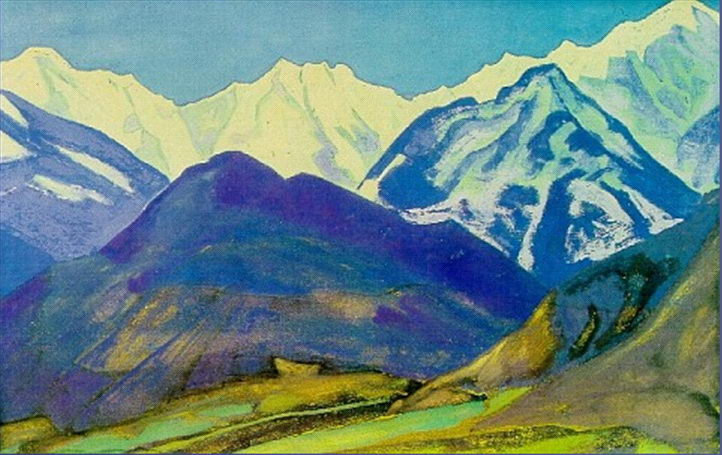Analyze the image in a comprehensive and detailed manner. The image is a vibrant depiction of a mountainous landscape, rendered in a post-impressionist style that embraces bold, expressive colors and dynamic brushstrokes. The mountains themselves are layered in hues of blue, green, and purple, each ridge and peak defined by contrasting colors that draw the viewer's eye across the panoramic scene. In the foreground, a lush valley stretches out, interspersed with specks of yellow and green undergrowth, leading to a tranquil blue body of water that reflects the sky. This artwork might convey a deep appreciation and yearning for the natural world, contrasting the untouched beauty of the mountains with the encroaching presence of human influence seen in the valley. This style suggests a subjective interpretation of the landscape, creating an emotional rather than just visual representation, which could evoke feelings of awe and solitude. 